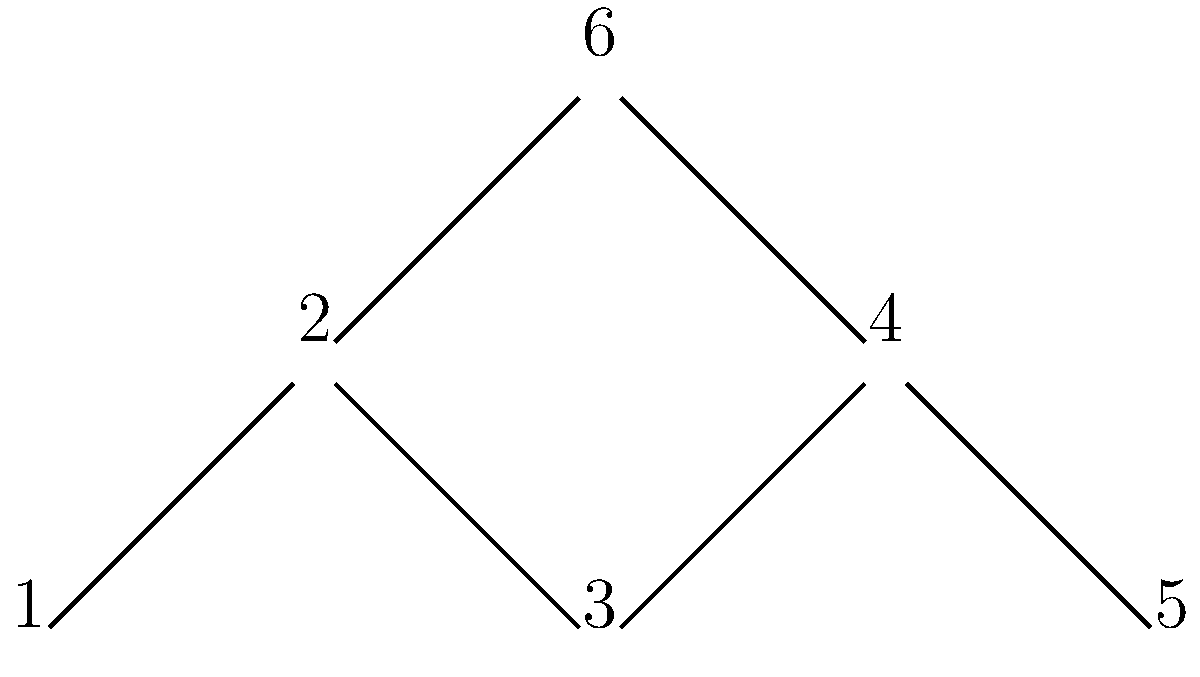In the context of modeling the spread of an infectious disease, the graph above represents a network of interconnected communities. Each node represents a community, and edges represent potential transmission pathways. Using the concept of betweenness centrality, which node would be the most critical to target for intervention to minimize the spread of the disease? To identify the most critical node for intervention, we need to calculate the betweenness centrality for each node. Betweenness centrality measures how often a node appears on the shortest paths between other nodes in the network. Here's a step-by-step approach:

1. Identify all shortest paths between pairs of nodes:
   - 1-2, 1-3, 1-4, 1-5, 1-6
   - 2-3, 2-4, 2-5, 2-6
   - 3-4, 3-5, 3-6
   - 4-5, 4-6
   - 5-6

2. Count how many times each node appears on these shortest paths:
   Node 1: 0 times
   Node 2: 1-3, 1-4, 1-5 (3 times)
   Node 3: 1-5 (1 time)
   Node 4: 2-5, 3-5 (2 times)
   Node 5: 0 times
   Node 6: 1-4, 2-4, 3-4 (3 times)

3. Normalize the counts by dividing by the total number of shortest paths:
   Node 1: 0/15 = 0
   Node 2: 3/15 = 0.2
   Node 3: 1/15 ≈ 0.067
   Node 4: 2/15 ≈ 0.133
   Node 5: 0/15 = 0
   Node 6: 3/15 = 0.2

4. Identify the node with the highest betweenness centrality:
   Nodes 2 and 6 have the highest betweenness centrality (0.2).

5. Consider the network structure:
   Node 2 connects the left side of the network (nodes 1 and 3) to the right side (nodes 4 and 5).
   Node 6 connects the upper part (nodes 2 and 3) to the lower part (nodes 4 and 5).

Given that node 2 acts as a bridge between two larger sections of the network, it would be the most critical node to target for intervention to minimize the spread of the disease.
Answer: Node 2 